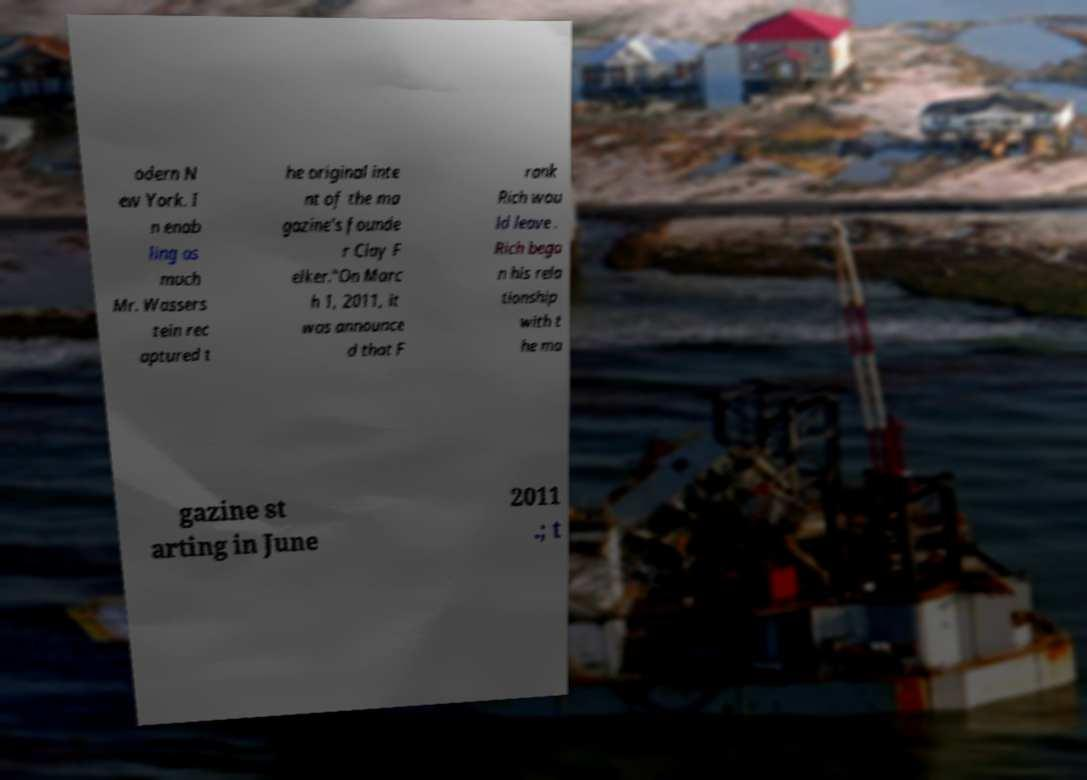Please read and relay the text visible in this image. What does it say? odern N ew York. I n enab ling as much Mr. Wassers tein rec aptured t he original inte nt of the ma gazine's founde r Clay F elker."On Marc h 1, 2011, it was announce d that F rank Rich wou ld leave . Rich bega n his rela tionship with t he ma gazine st arting in June 2011 .; t 